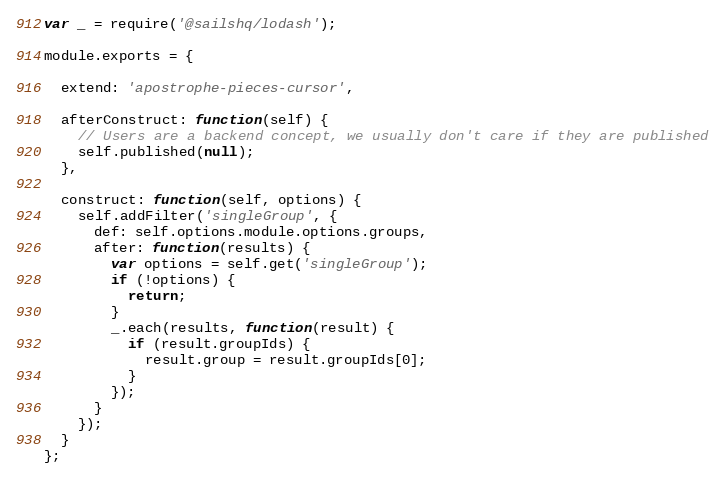<code> <loc_0><loc_0><loc_500><loc_500><_JavaScript_>var _ = require('@sailshq/lodash');

module.exports = {

  extend: 'apostrophe-pieces-cursor',

  afterConstruct: function(self) {
    // Users are a backend concept, we usually don't care if they are published
    self.published(null);
  },

  construct: function(self, options) {
    self.addFilter('singleGroup', {
      def: self.options.module.options.groups,
      after: function(results) {
        var options = self.get('singleGroup');
        if (!options) {
          return;
        }
        _.each(results, function(result) {
          if (result.groupIds) {
            result.group = result.groupIds[0];
          }
        });
      }
    });
  }
};
</code> 